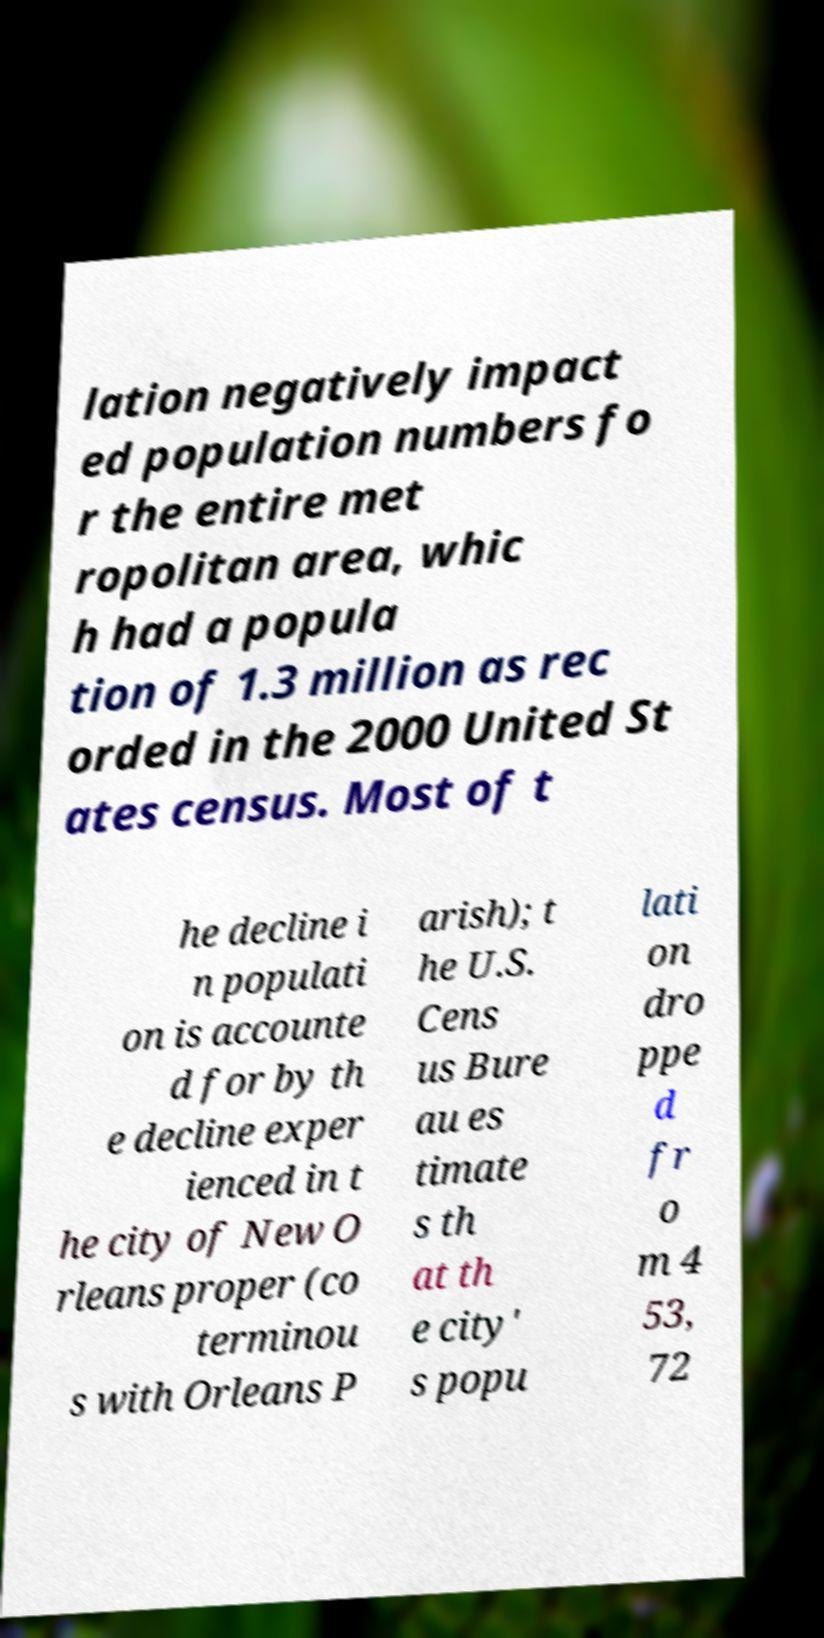What messages or text are displayed in this image? I need them in a readable, typed format. lation negatively impact ed population numbers fo r the entire met ropolitan area, whic h had a popula tion of 1.3 million as rec orded in the 2000 United St ates census. Most of t he decline i n populati on is accounte d for by th e decline exper ienced in t he city of New O rleans proper (co terminou s with Orleans P arish); t he U.S. Cens us Bure au es timate s th at th e city' s popu lati on dro ppe d fr o m 4 53, 72 